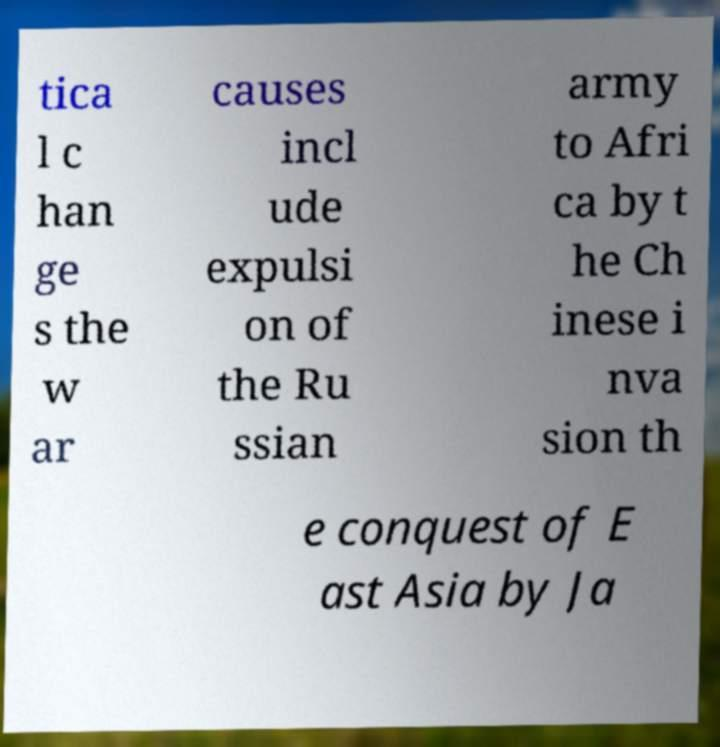Please identify and transcribe the text found in this image. tica l c han ge s the w ar causes incl ude expulsi on of the Ru ssian army to Afri ca by t he Ch inese i nva sion th e conquest of E ast Asia by Ja 